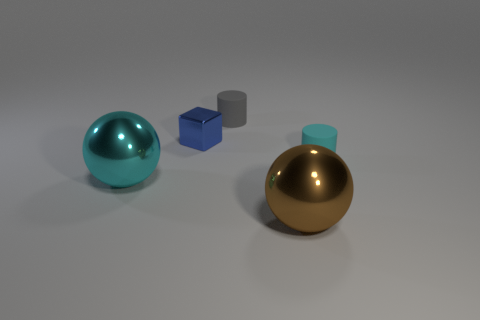Is there anything else that has the same shape as the blue metallic object?
Your answer should be compact. No. What material is the small cyan object that is the same shape as the gray object?
Offer a terse response. Rubber. There is a shiny object behind the small cyan thing; what number of large metallic things are left of it?
Give a very brief answer. 1. How big is the metallic ball to the left of the tiny matte cylinder left of the big thing that is in front of the cyan sphere?
Your response must be concise. Large. The metal object that is in front of the big sphere to the left of the large brown ball is what color?
Give a very brief answer. Brown. How many other objects are the same material as the small cyan object?
Provide a short and direct response. 1. How many other things are the same color as the cube?
Provide a succinct answer. 0. The cyan object that is behind the large object to the left of the gray object is made of what material?
Provide a succinct answer. Rubber. Are there any small cyan metal cylinders?
Offer a terse response. No. What size is the sphere on the right side of the rubber cylinder behind the metal block?
Your response must be concise. Large. 